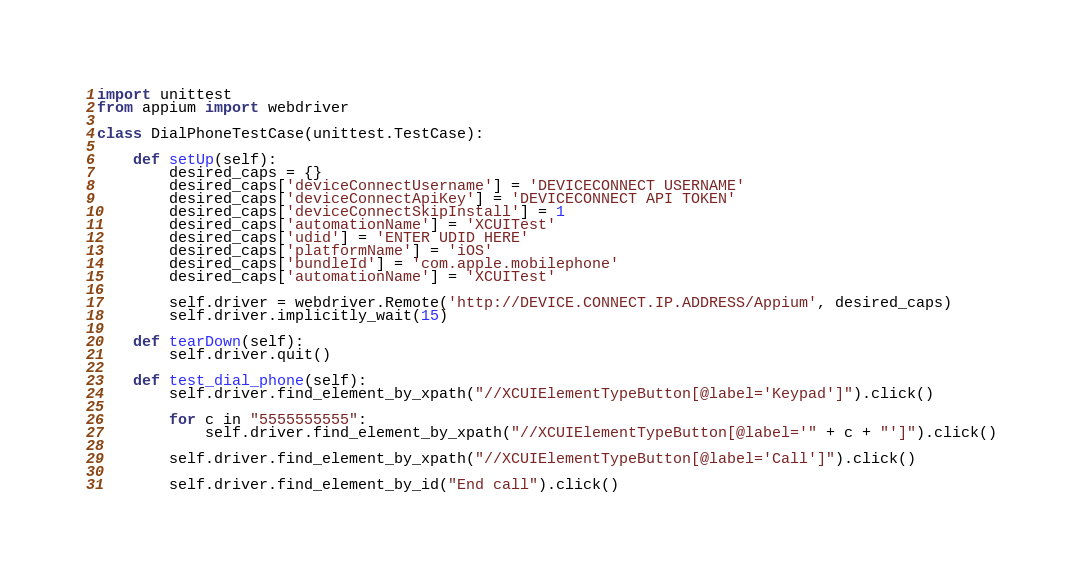<code> <loc_0><loc_0><loc_500><loc_500><_Python_>import unittest
from appium import webdriver

class DialPhoneTestCase(unittest.TestCase):

    def setUp(self):
        desired_caps = {}
        desired_caps['deviceConnectUsername'] = 'DEVICECONNECT USERNAME'
        desired_caps['deviceConnectApiKey'] = 'DEVICECONNECT API TOKEN'
        desired_caps['deviceConnectSkipInstall'] = 1
        desired_caps['automationName'] = 'XCUITest'
        desired_caps['udid'] = 'ENTER UDID HERE'
        desired_caps['platformName'] = 'iOS'
        desired_caps['bundleId'] = 'com.apple.mobilephone'
        desired_caps['automationName'] = 'XCUITest'

        self.driver = webdriver.Remote('http://DEVICE.CONNECT.IP.ADDRESS/Appium', desired_caps)
        self.driver.implicitly_wait(15)

    def tearDown(self):
        self.driver.quit()

    def test_dial_phone(self):
        self.driver.find_element_by_xpath("//XCUIElementTypeButton[@label='Keypad']").click()

        for c in "5555555555":
            self.driver.find_element_by_xpath("//XCUIElementTypeButton[@label='" + c + "']").click()

        self.driver.find_element_by_xpath("//XCUIElementTypeButton[@label='Call']").click()

        self.driver.find_element_by_id("End call").click()
</code> 